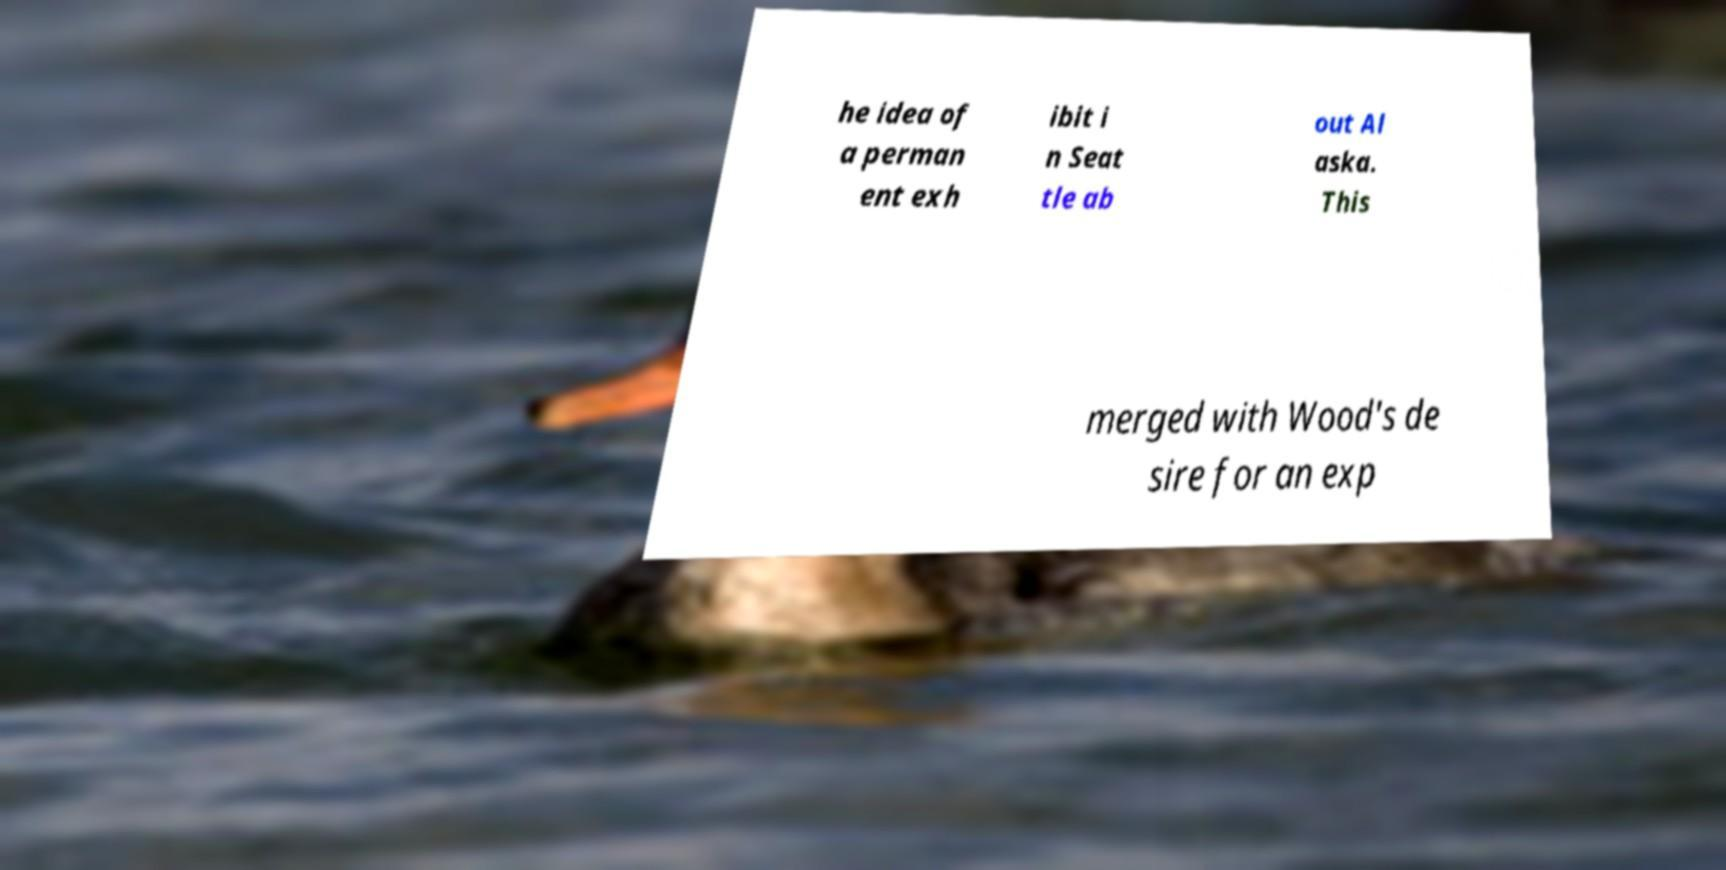I need the written content from this picture converted into text. Can you do that? he idea of a perman ent exh ibit i n Seat tle ab out Al aska. This merged with Wood's de sire for an exp 